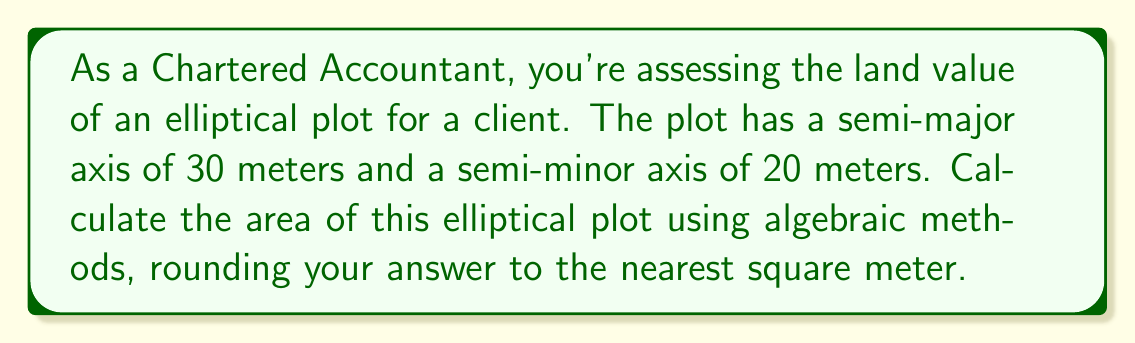Could you help me with this problem? Let's approach this step-by-step:

1) The formula for the area of an ellipse is:

   $$A = \pi ab$$

   where $a$ is the length of the semi-major axis and $b$ is the length of the semi-minor axis.

2) We're given:
   $a = 30$ meters
   $b = 20$ meters

3) Substituting these values into our formula:

   $$A = \pi (30)(20)$$

4) Simplify:
   $$A = 600\pi$$

5) To calculate this:
   $$A \approx 600 * 3.14159 = 1884.954$$

6) Rounding to the nearest square meter:
   $$A \approx 1885 \text{ m}^2$$

This algebraic method allows us to quickly calculate the area without resorting to geometric approximations, which is crucial for accurate land valuation in accounting practices.
Answer: 1885 m² 